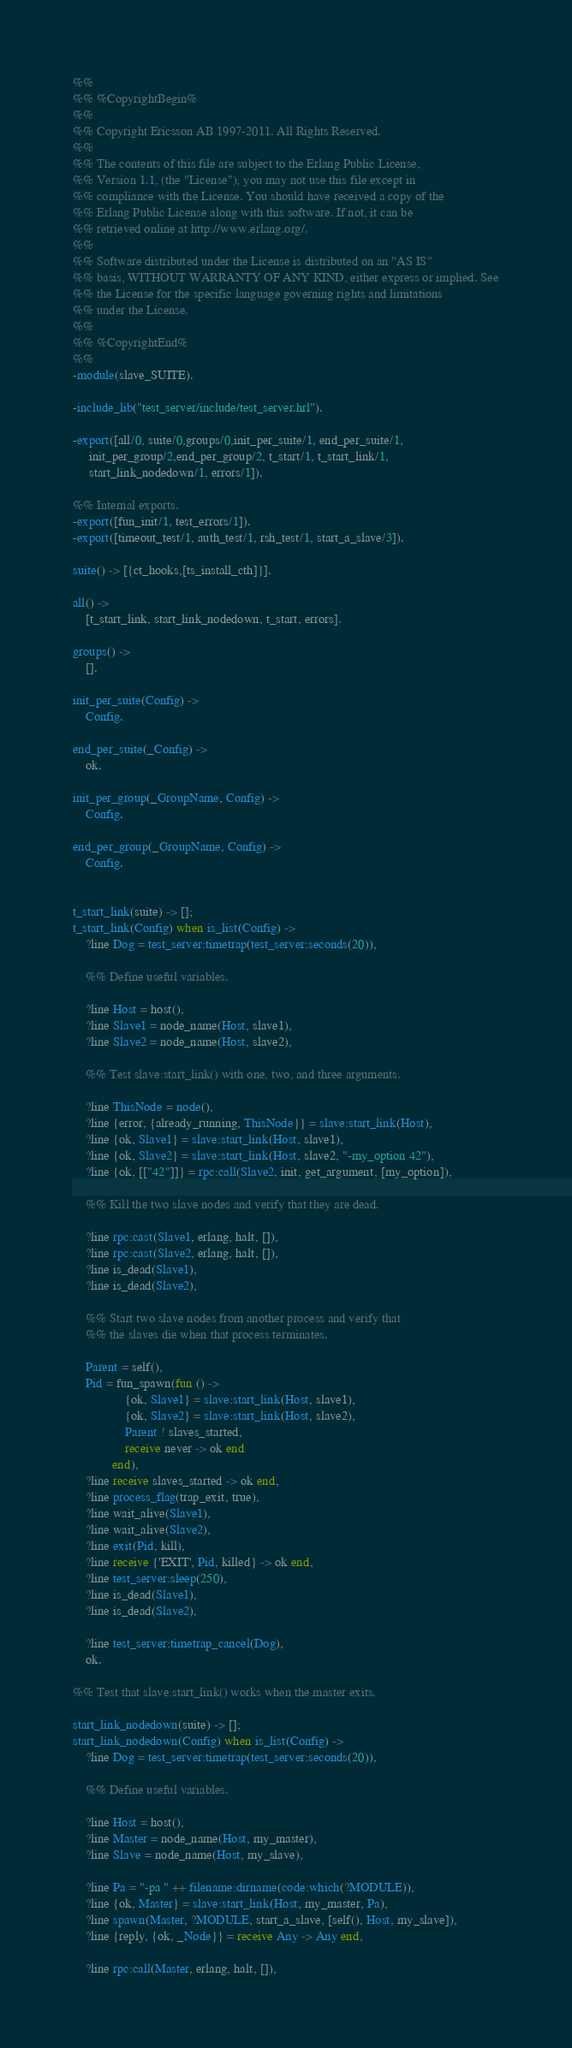<code> <loc_0><loc_0><loc_500><loc_500><_Erlang_>%%
%% %CopyrightBegin%
%%
%% Copyright Ericsson AB 1997-2011. All Rights Reserved.
%%
%% The contents of this file are subject to the Erlang Public License,
%% Version 1.1, (the "License"); you may not use this file except in
%% compliance with the License. You should have received a copy of the
%% Erlang Public License along with this software. If not, it can be
%% retrieved online at http://www.erlang.org/.
%%
%% Software distributed under the License is distributed on an "AS IS"
%% basis, WITHOUT WARRANTY OF ANY KIND, either express or implied. See
%% the License for the specific language governing rights and limitations
%% under the License.
%%
%% %CopyrightEnd%
%%
-module(slave_SUITE).

-include_lib("test_server/include/test_server.hrl").

-export([all/0, suite/0,groups/0,init_per_suite/1, end_per_suite/1, 
	 init_per_group/2,end_per_group/2, t_start/1, t_start_link/1,
	 start_link_nodedown/1, errors/1]).

%% Internal exports.
-export([fun_init/1, test_errors/1]).
-export([timeout_test/1, auth_test/1, rsh_test/1, start_a_slave/3]).

suite() -> [{ct_hooks,[ts_install_cth]}].

all() -> 
    [t_start_link, start_link_nodedown, t_start, errors].

groups() -> 
    [].

init_per_suite(Config) ->
    Config.

end_per_suite(_Config) ->
    ok.

init_per_group(_GroupName, Config) ->
    Config.

end_per_group(_GroupName, Config) ->
    Config.


t_start_link(suite) -> [];
t_start_link(Config) when is_list(Config) ->
    ?line Dog = test_server:timetrap(test_server:seconds(20)),

    %% Define useful variables.

    ?line Host = host(),
    ?line Slave1 = node_name(Host, slave1),
    ?line Slave2 = node_name(Host, slave2),

    %% Test slave:start_link() with one, two, and three arguments.

    ?line ThisNode = node(),
    ?line {error, {already_running, ThisNode}} = slave:start_link(Host),
    ?line {ok, Slave1} = slave:start_link(Host, slave1),
    ?line {ok, Slave2} = slave:start_link(Host, slave2, "-my_option 42"),
    ?line {ok, [["42"]]} = rpc:call(Slave2, init, get_argument, [my_option]),

    %% Kill the two slave nodes and verify that they are dead.

    ?line rpc:cast(Slave1, erlang, halt, []),
    ?line rpc:cast(Slave2, erlang, halt, []),
    ?line is_dead(Slave1),
    ?line is_dead(Slave2),

    %% Start two slave nodes from another process and verify that
    %% the slaves die when that process terminates.

    Parent = self(),
    Pid = fun_spawn(fun () ->
			    {ok, Slave1} = slave:start_link(Host, slave1),
			    {ok, Slave2} = slave:start_link(Host, slave2),
			    Parent ! slaves_started,
			    receive never -> ok end
		    end),
    ?line receive slaves_started -> ok end,
    ?line process_flag(trap_exit, true),
    ?line wait_alive(Slave1),
    ?line wait_alive(Slave2),
    ?line exit(Pid, kill),
    ?line receive {'EXIT', Pid, killed} -> ok end,
    ?line test_server:sleep(250),
    ?line is_dead(Slave1),
    ?line is_dead(Slave2),
		  
    ?line test_server:timetrap_cancel(Dog),
    ok.

%% Test that slave:start_link() works when the master exits.

start_link_nodedown(suite) -> [];
start_link_nodedown(Config) when is_list(Config) ->
    ?line Dog = test_server:timetrap(test_server:seconds(20)),

    %% Define useful variables.

    ?line Host = host(),
    ?line Master = node_name(Host, my_master),
    ?line Slave = node_name(Host, my_slave),

    ?line Pa = "-pa " ++ filename:dirname(code:which(?MODULE)),
    ?line {ok, Master} = slave:start_link(Host, my_master, Pa),
    ?line spawn(Master, ?MODULE, start_a_slave, [self(), Host, my_slave]),
    ?line {reply, {ok, _Node}} = receive Any -> Any end,
    
    ?line rpc:call(Master, erlang, halt, []),</code> 